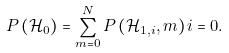<formula> <loc_0><loc_0><loc_500><loc_500>P \left ( { \mathcal { H } } _ { 0 } \right ) = \sum _ { m = 0 } ^ { N } { P \left ( { \mathcal { H } } _ { 1 , i } , m \right ) i = 0 } .</formula> 